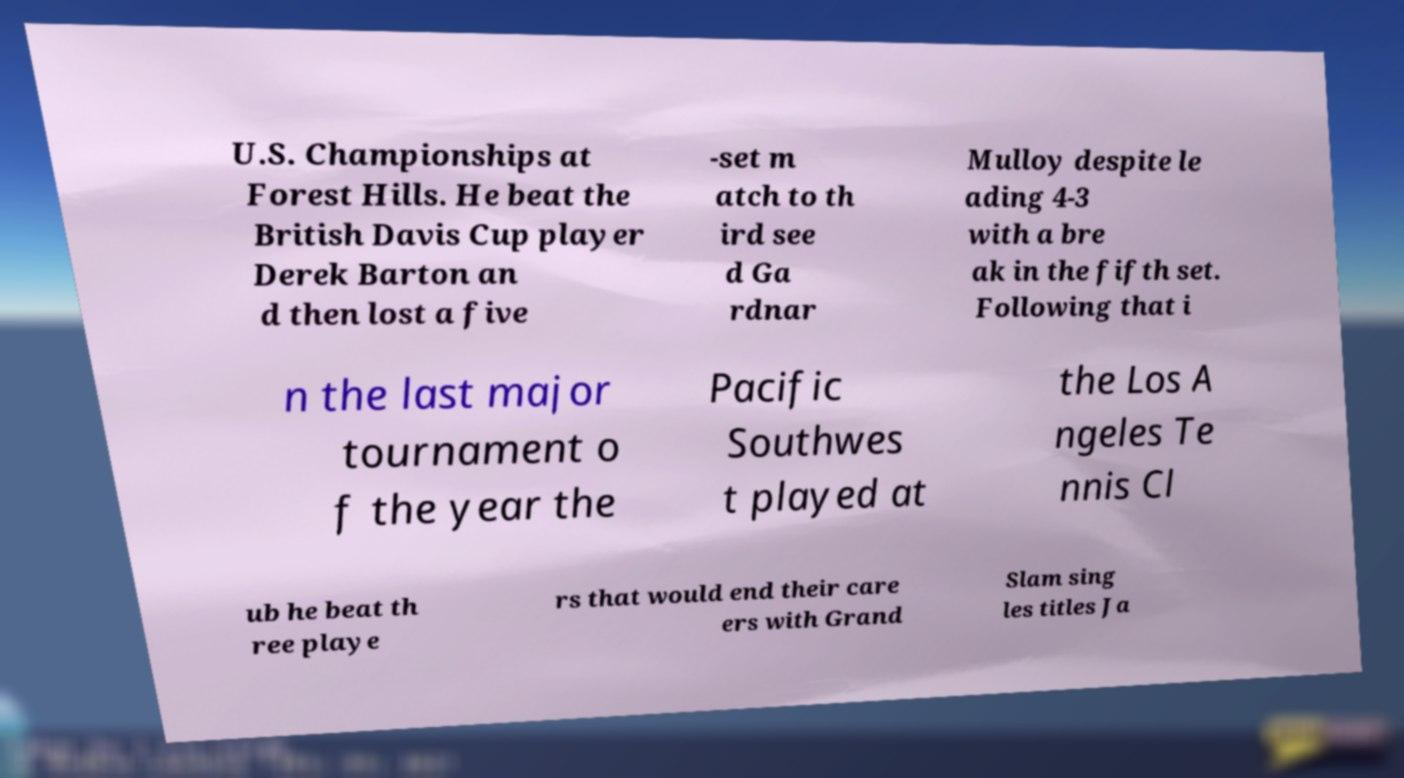Can you accurately transcribe the text from the provided image for me? U.S. Championships at Forest Hills. He beat the British Davis Cup player Derek Barton an d then lost a five -set m atch to th ird see d Ga rdnar Mulloy despite le ading 4-3 with a bre ak in the fifth set. Following that i n the last major tournament o f the year the Pacific Southwes t played at the Los A ngeles Te nnis Cl ub he beat th ree playe rs that would end their care ers with Grand Slam sing les titles Ja 